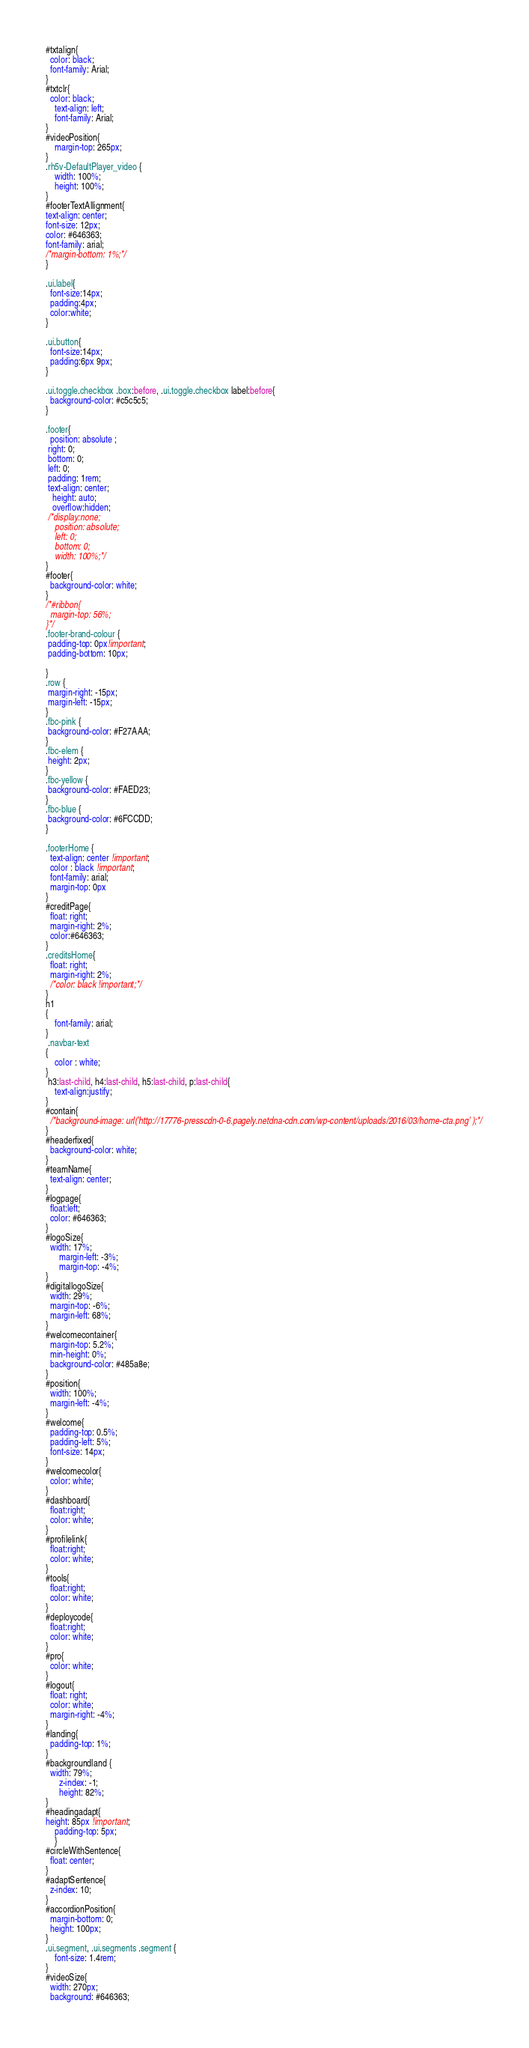Convert code to text. <code><loc_0><loc_0><loc_500><loc_500><_CSS_>
#txtalign{
  color: black;
  font-family: Arial;
}
#txtclr{
  color: black;
    text-align: left;
    font-family: Arial;
}
#videoPosition{
    margin-top: 265px;
}
.rh5v-DefaultPlayer_video {
    width: 100%;
    height: 100%;
}
#footerTextAllignment{
text-align: center;
font-size: 12px;
color: #646363;
font-family: arial;
/*margin-bottom: 1%;*/
}

.ui.label{
  font-size:14px;
  padding:4px;
  color:white;
}

.ui.button{
  font-size:14px;
  padding:6px 9px;
}

.ui.toggle.checkbox .box:before, .ui.toggle.checkbox label:before{
  background-color: #c5c5c5;
}

.footer{
  position: absolute ;
 right: 0;
 bottom: 0;
 left: 0;
 padding: 1rem;
 text-align: center;
   height: auto;
   overflow:hidden;
 /*display:none;
    position: absolute;
    left: 0;
    bottom: 0;
    width: 100%;*/
}
#footer{
  background-color: white;
}
/*#ribbon{
  margin-top: 56%;
}*/
.footer-brand-colour {
 padding-top: 0px!important; 
 padding-bottom: 10px;

}
.row {
 margin-right: -15px; 
 margin-left: -15px;
}
.fbc-pink {
 background-color: #F27AAA;
}
.fbc-elem {
 height: 2px;
}
.fbc-yellow {
 background-color: #FAED23;
}
.fbc-blue {
 background-color: #6FCCDD;
}

.footerHome {
  text-align: center !important;
  color : black !important;
  font-family: arial;
  margin-top: 0px
}
#creditPage{
  float: right;
  margin-right: 2%;
  color:#646363;
}
.creditsHome{
  float: right;
  margin-right: 2%;
  /*color: black !important;*/
}
h1
{
    font-family: arial;
}
 .navbar-text
{
    color : white;
}
 h3:last-child, h4:last-child, h5:last-child, p:last-child{
    text-align:justify;
}
#contain{
  /*background-image: url('http://17776-presscdn-0-6.pagely.netdna-cdn.com/wp-content/uploads/2016/03/home-cta.png' );*/
}
#headerfixed{
  background-color: white;
}
#teamName{
  text-align: center;
}
#logpage{
  float:left;
  color: #646363;
}
#logoSize{
  width: 17%;
      margin-left: -3%;
      margin-top: -4%;
}
#digitallogoSize{
  width: 29%;
  margin-top: -6%;
  margin-left: 68%;
}
#welcomecontainer{
  margin-top: 5.2%;
  min-height: 0%;
  background-color: #485a8e;
}
#position{
  width: 100%;
  margin-left: -4%;
}
#welcome{
  padding-top: 0.5%;
  padding-left: 5%;
  font-size: 14px;
}
#welcomecolor{
  color: white;
}
#dashboard{
  float:right;
  color: white;
}
#profilelink{
  float:right;
  color: white;
}
#tools{
  float:right;
  color: white;
}
#deploycode{
  float:right;
  color: white;
}
#pro{
  color: white;
}
#logout{
  float: right;
  color: white;
  margin-right: -4%;
}
#landing{
  padding-top: 1%;
}
#backgroundland {
  width: 79%;
      z-index: -1;
      height: 82%;
}
#headingadapt{
height: 85px !important;
    padding-top: 5px;
    }
#circleWithSentence{
  float: center;
}
#adaptSentence{
  z-index: 10;
}
#accordionPosition{
  margin-bottom: 0;
  height: 100px;
}
.ui.segment, .ui.segments .segment {
    font-size: 1.4rem;
}
#videoSize{
  width: 270px;
  background: #646363;</code> 